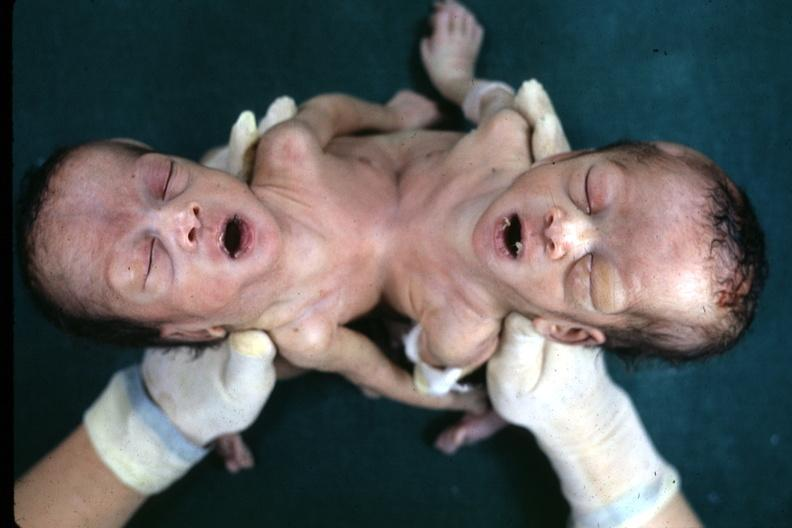what joined lower chest and abdomen?
Answer the question using a single word or phrase. View looking down on heads 